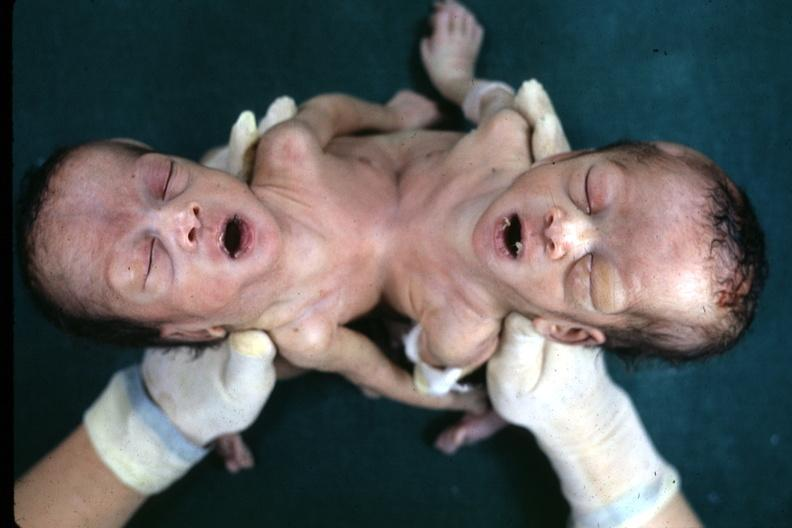what joined lower chest and abdomen?
Answer the question using a single word or phrase. View looking down on heads 